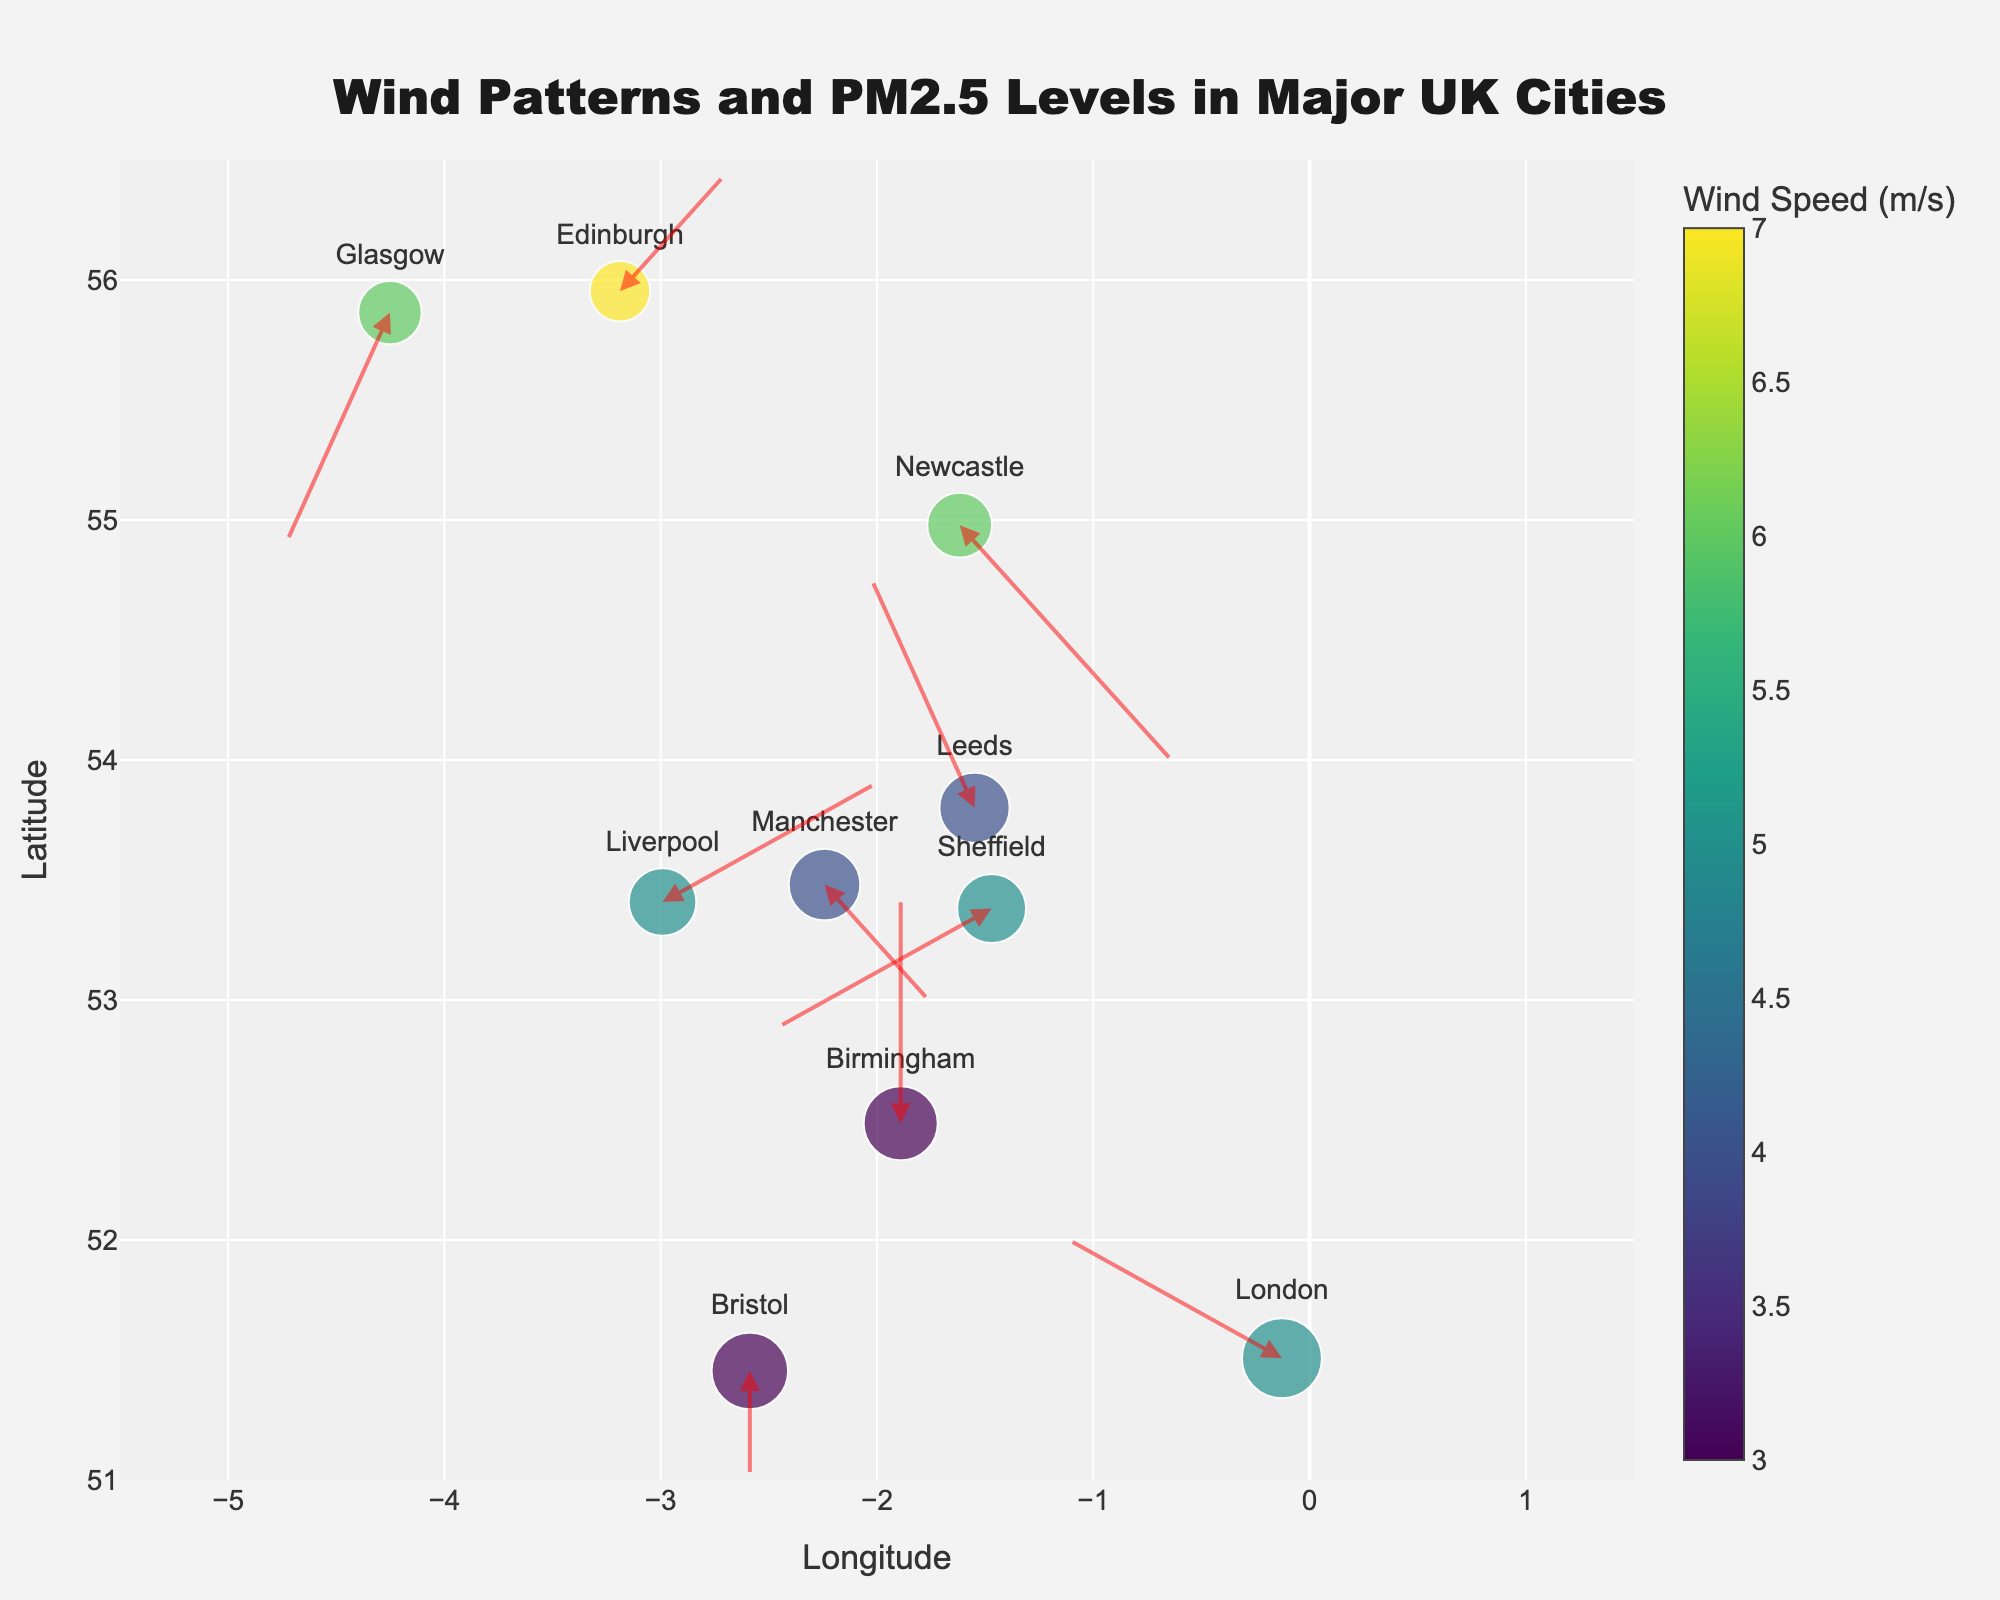What is the title of the figure? The title is usually located at the top of the figure. It provides a brief description of what the figure is about. In this case, it's given as "Wind Patterns and PM2.5 Levels in Major UK Cities"
Answer: Wind Patterns and PM2.5 Levels in Major UK Cities Which city has the highest PM2.5 level? To find this, look at the size of the markers since PM2.5 levels are represented by the size of the markers. Find the largest marker and identify the city it corresponds to.
Answer: London What is the wind speed in Edinburgh? Wind speed is represented by the color of the markers, with the color scale shown on the color bar. Hovering over Edinburgh provides the exact value.
Answer: 7 m/s How many cities have a PM2.5 level above 30? Count the number of markers that are relatively larger as 30 is used as a threshold for PM2.5 level. Specifically, look for cities with hover text showing PM2.5 levels above 30.
Answer: 3 Which city has the most southward wind direction? Look at the direction and length of the arrows. For southward direction, the arrow should point downward, and the city with the longest downward arrow has the most southward wind direction.
Answer: Glasgow Compare the wind direction between Liverpool and Newcastle. Observe the direction of the arrows pointing from Liverpool and Newcastle. The arrows for both cities should be checked to see if they point in similar or different directions. Liverpool has a wind direction heading eastward (right), while Newcastle has a south-eastward (down-right) direction.
Answer: Different directions What is the average PM2.5 level across all cities? Sum the PM2.5 levels for all cities (35+28+30+22+25+27+20+32+26+23) and divide by the number of cities (10).
Answer: 26.8 Which city experiences the weakest winds? Find the lightest colored marker, as wind speed is represented by the colors. Hover over it to confirm.
Answer: Birmingham Is there a correlation between wind speed and PM2.5 levels? Look at the color and size of the markers. If high wind speed (darker colors) corresponds mostly to low PM2.5 levels (smaller markers) and vice versa, there is an inverse correlation.
Answer: Yes, inverse correlation What’s the general wind direction in London? According to the direction of the arrow originating from London, the wind direction can be seen as slightly northwest (up-left).
Answer: Northwest 